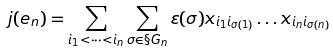<formula> <loc_0><loc_0><loc_500><loc_500>j ( e _ { n } ) = \sum _ { i _ { 1 } < \cdots < i _ { n } } \sum _ { \sigma \in \S G _ { n } } \varepsilon ( \sigma ) x _ { i _ { 1 } i _ { \sigma ( 1 ) } } \dots x _ { i _ { n } i _ { \sigma ( n ) } }</formula> 